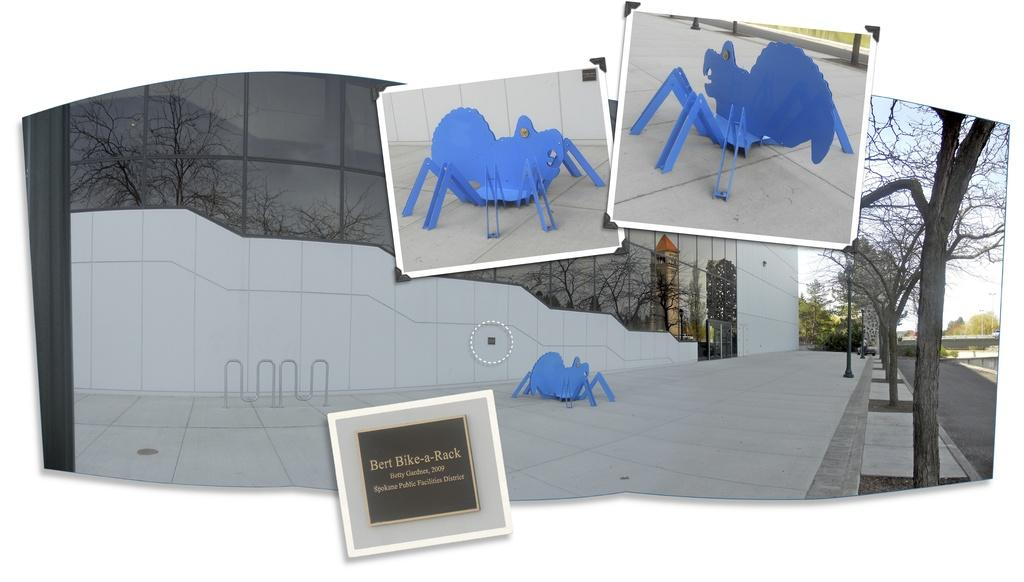<image>
Write a terse but informative summary of the picture. Bert's Bike Rack sits on the cement in front of large windows next to a giant blue spider. 